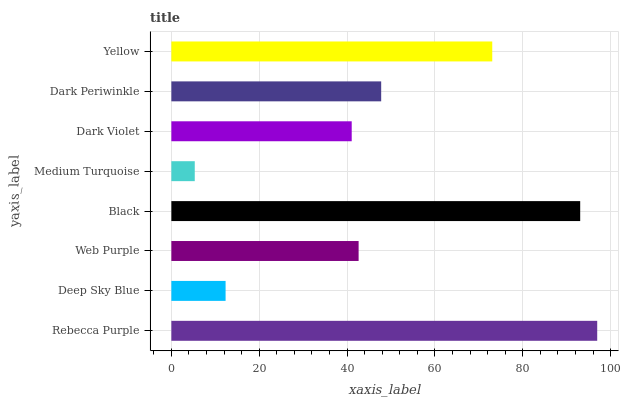Is Medium Turquoise the minimum?
Answer yes or no. Yes. Is Rebecca Purple the maximum?
Answer yes or no. Yes. Is Deep Sky Blue the minimum?
Answer yes or no. No. Is Deep Sky Blue the maximum?
Answer yes or no. No. Is Rebecca Purple greater than Deep Sky Blue?
Answer yes or no. Yes. Is Deep Sky Blue less than Rebecca Purple?
Answer yes or no. Yes. Is Deep Sky Blue greater than Rebecca Purple?
Answer yes or no. No. Is Rebecca Purple less than Deep Sky Blue?
Answer yes or no. No. Is Dark Periwinkle the high median?
Answer yes or no. Yes. Is Web Purple the low median?
Answer yes or no. Yes. Is Medium Turquoise the high median?
Answer yes or no. No. Is Yellow the low median?
Answer yes or no. No. 